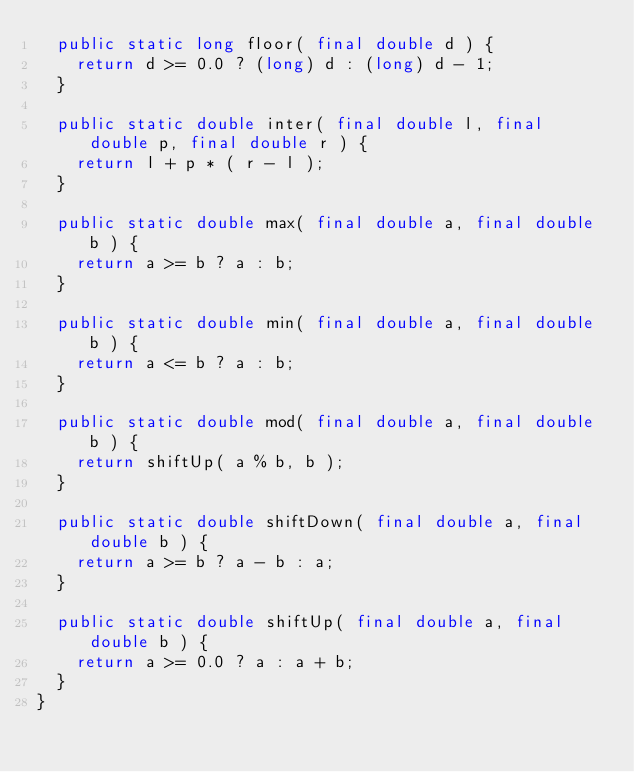<code> <loc_0><loc_0><loc_500><loc_500><_Java_>  public static long floor( final double d ) {
    return d >= 0.0 ? (long) d : (long) d - 1;
  }
  
  public static double inter( final double l, final double p, final double r ) {
    return l + p * ( r - l );
  }
  
  public static double max( final double a, final double b ) {
    return a >= b ? a : b;
  }
  
  public static double min( final double a, final double b ) {
    return a <= b ? a : b;
  }
  
  public static double mod( final double a, final double b ) {
    return shiftUp( a % b, b );
  }
  
  public static double shiftDown( final double a, final double b ) {
    return a >= b ? a - b : a;
  }
  
  public static double shiftUp( final double a, final double b ) {
    return a >= 0.0 ? a : a + b;
  }
}</code> 